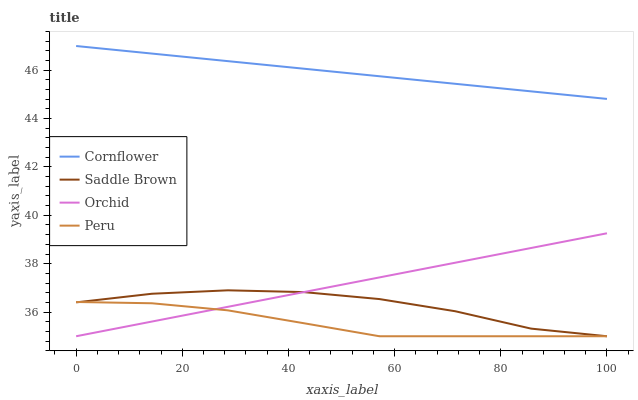Does Peru have the minimum area under the curve?
Answer yes or no. Yes. Does Cornflower have the maximum area under the curve?
Answer yes or no. Yes. Does Saddle Brown have the minimum area under the curve?
Answer yes or no. No. Does Saddle Brown have the maximum area under the curve?
Answer yes or no. No. Is Orchid the smoothest?
Answer yes or no. Yes. Is Saddle Brown the roughest?
Answer yes or no. Yes. Is Peru the smoothest?
Answer yes or no. No. Is Peru the roughest?
Answer yes or no. No. Does Saddle Brown have the lowest value?
Answer yes or no. Yes. Does Cornflower have the highest value?
Answer yes or no. Yes. Does Saddle Brown have the highest value?
Answer yes or no. No. Is Peru less than Cornflower?
Answer yes or no. Yes. Is Cornflower greater than Orchid?
Answer yes or no. Yes. Does Orchid intersect Saddle Brown?
Answer yes or no. Yes. Is Orchid less than Saddle Brown?
Answer yes or no. No. Is Orchid greater than Saddle Brown?
Answer yes or no. No. Does Peru intersect Cornflower?
Answer yes or no. No. 